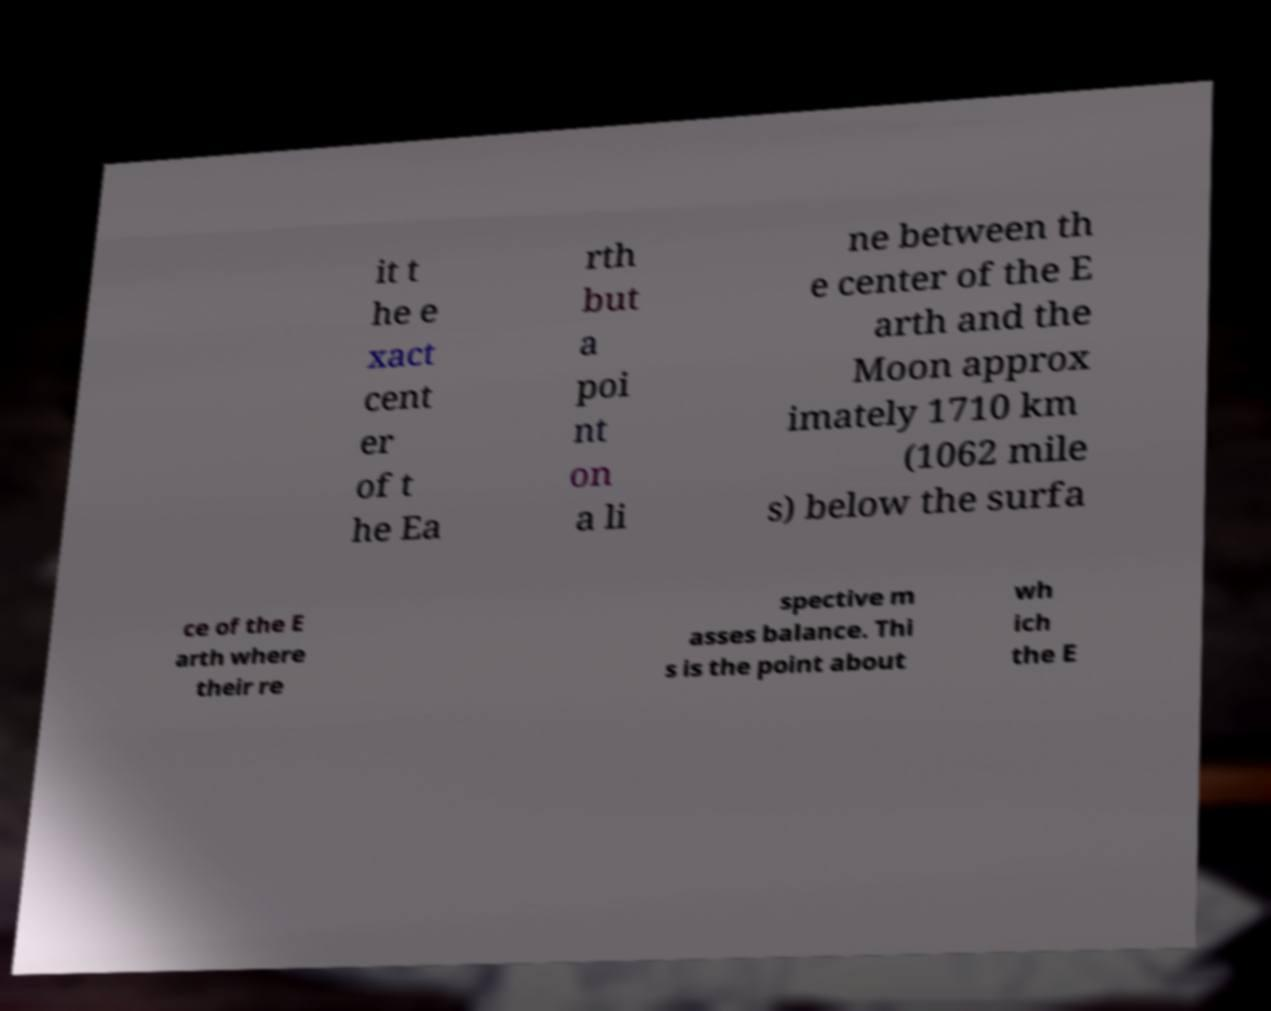Please identify and transcribe the text found in this image. it t he e xact cent er of t he Ea rth but a poi nt on a li ne between th e center of the E arth and the Moon approx imately 1710 km (1062 mile s) below the surfa ce of the E arth where their re spective m asses balance. Thi s is the point about wh ich the E 